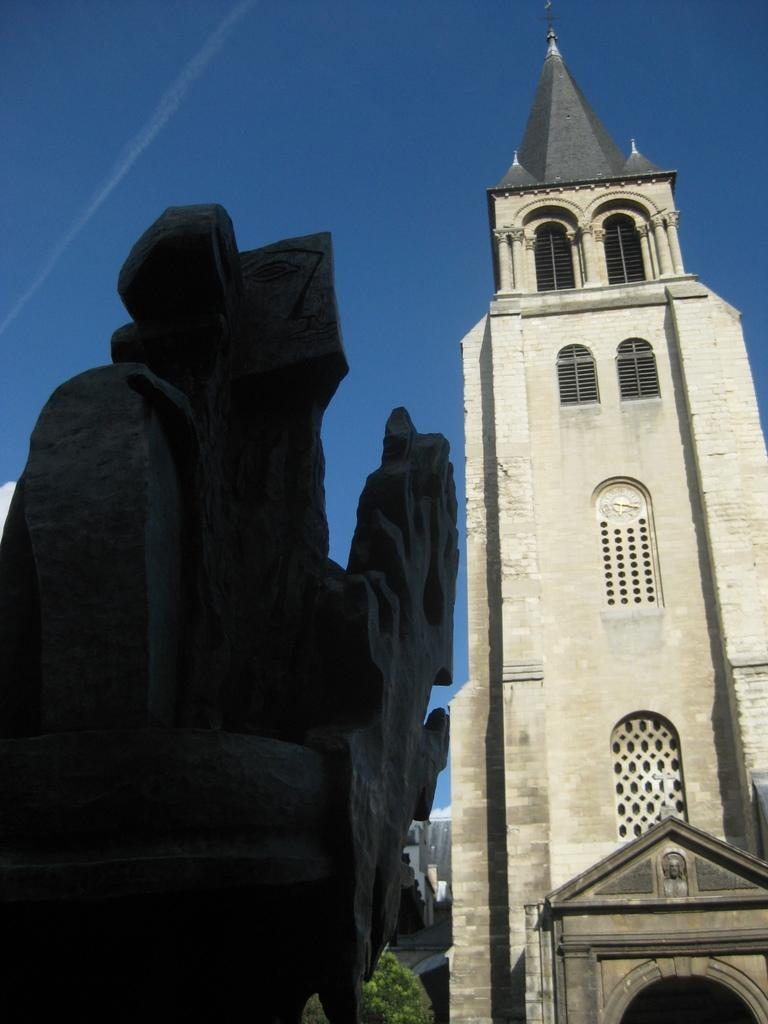What type of structure can be seen in the image? There is a building in the image. What part of the natural environment is visible in the image? The sky is visible in the image. What type of plant is present in the image? There is a tree in the image. Can you describe the unspecified object in the image? Unfortunately, the facts provided do not give any details about the unspecified object, so we cannot describe it. What type of pets can be seen in the image? There are no pets visible in the image. On which channel can the building be seen in the image? The image is not a video or television broadcast, so there is no channel associated with it. 